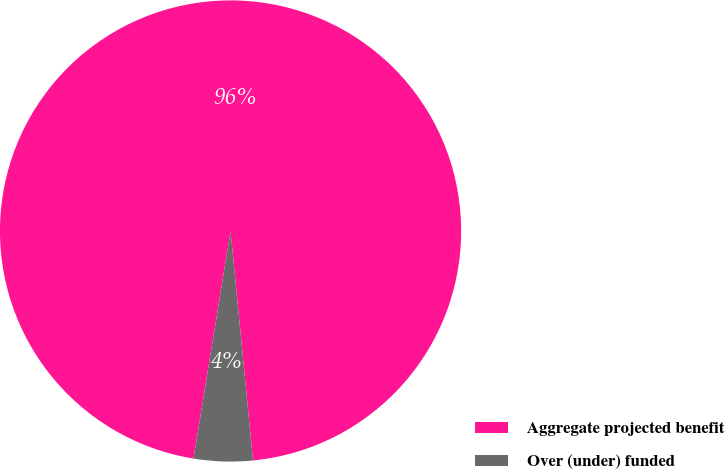Convert chart. <chart><loc_0><loc_0><loc_500><loc_500><pie_chart><fcel>Aggregate projected benefit<fcel>Over (under) funded<nl><fcel>95.88%<fcel>4.12%<nl></chart> 